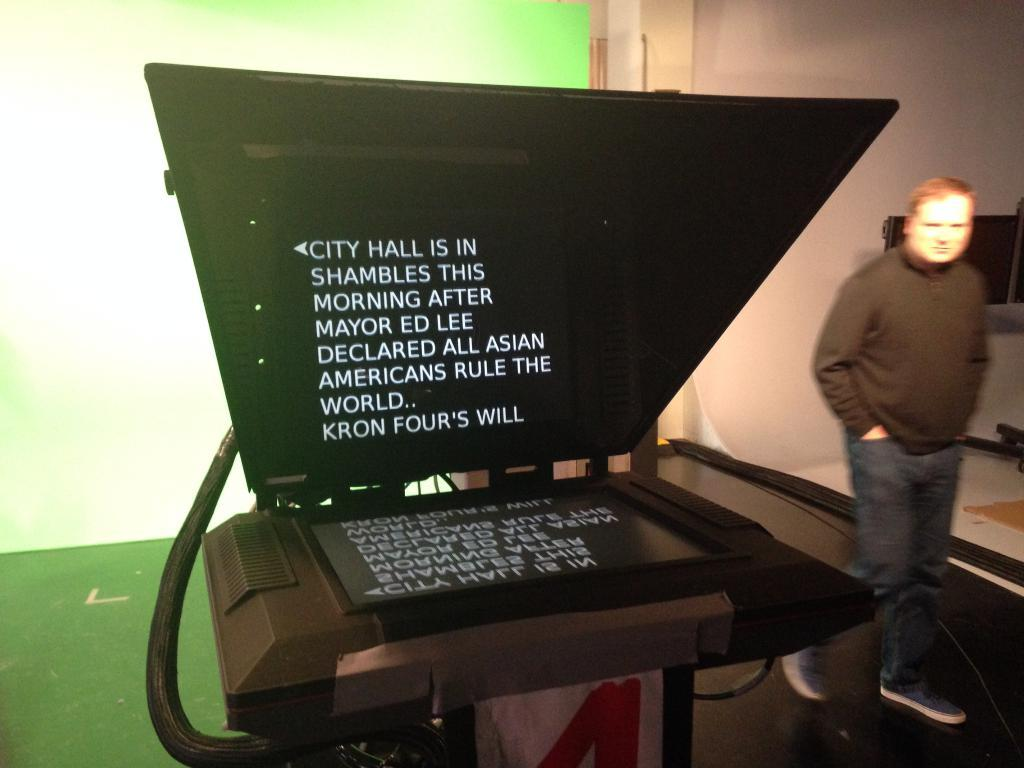What is the main feature of the image? There is a black screen in the image. What is written on the black screen? Some matter is written on the black screen. Can you describe the man in the image? The man is wearing a black t-shirt and is walking. What is the color of the background in the image? The background in the image is green. How far away is the sponge from the man in the image? There is no sponge present in the image, so it cannot be determined how far away it might be from the man. 